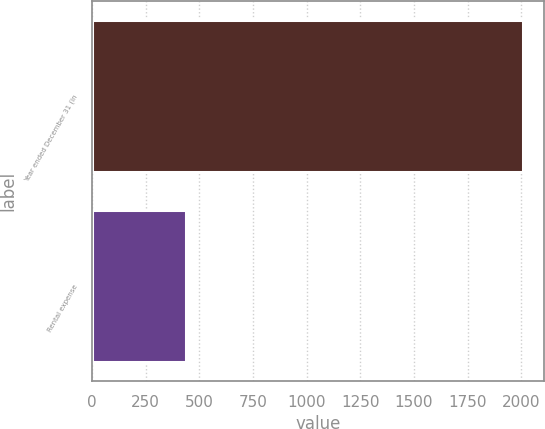Convert chart to OTSL. <chart><loc_0><loc_0><loc_500><loc_500><bar_chart><fcel>Year ended December 31 (in<fcel>Rental expense<nl><fcel>2008<fcel>436<nl></chart> 